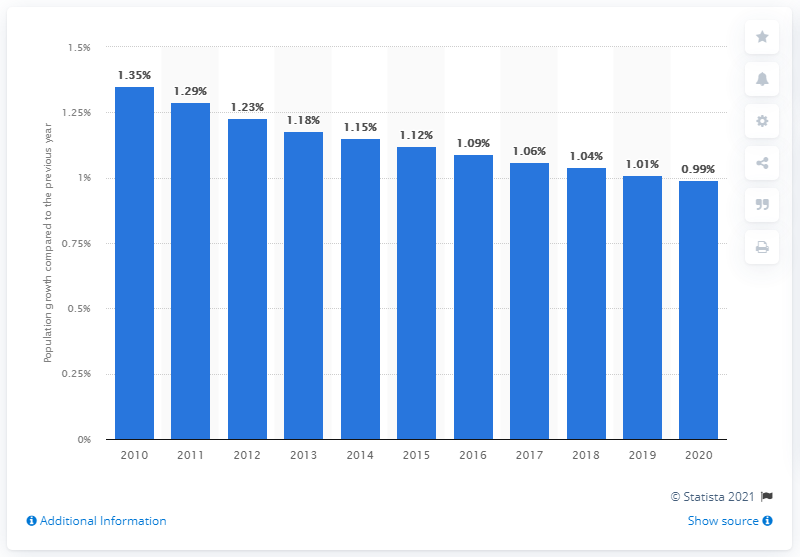Point out several critical features in this image. According to the latest estimates, the population of India grew by 0.99% in 2020. 